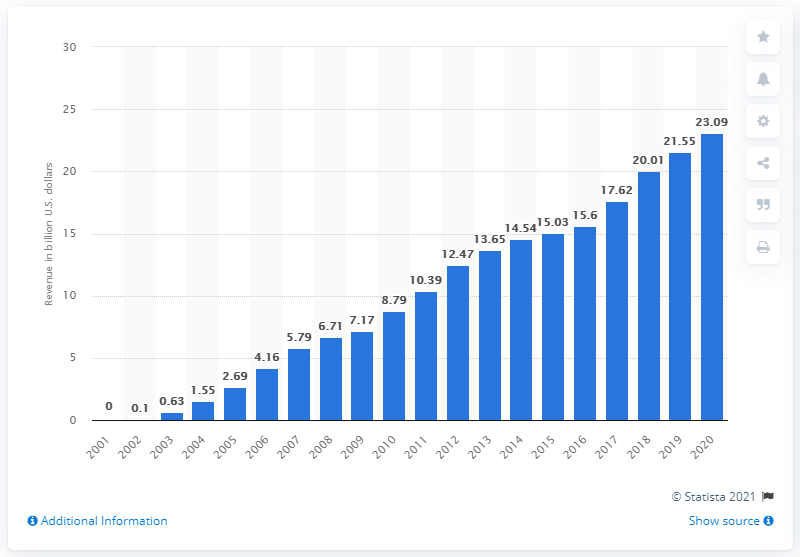List a handful of essential elements in this visual. As of the most recent report period, the advertising revenue of Google network sites was $23.09. 